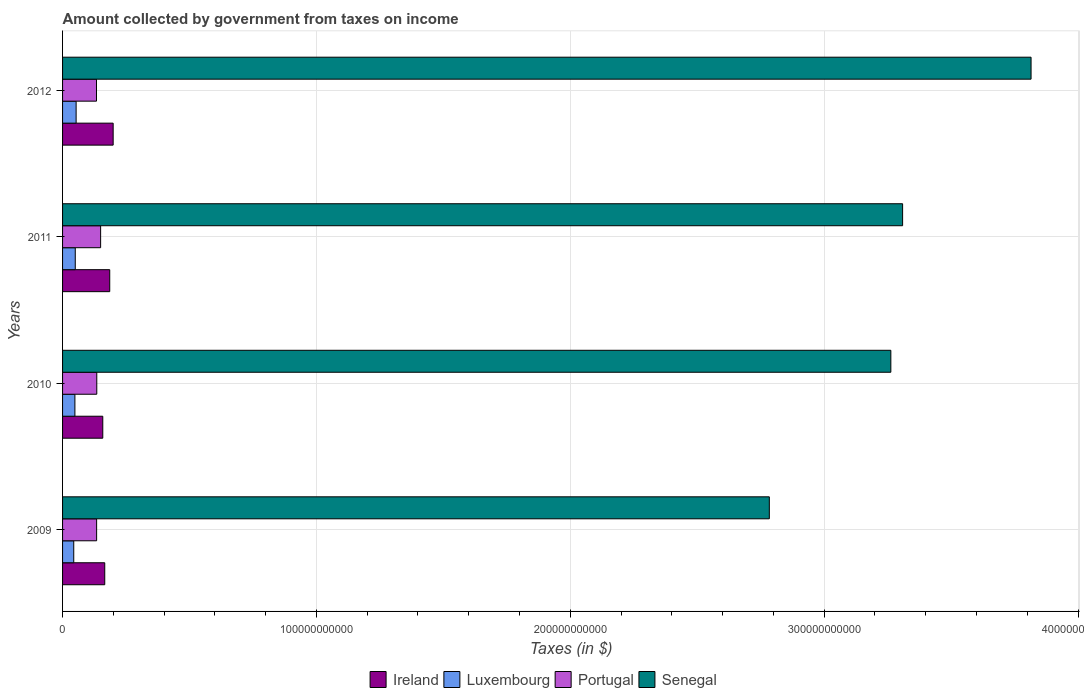How many different coloured bars are there?
Make the answer very short. 4. How many groups of bars are there?
Make the answer very short. 4. Are the number of bars per tick equal to the number of legend labels?
Provide a short and direct response. Yes. Are the number of bars on each tick of the Y-axis equal?
Make the answer very short. Yes. How many bars are there on the 1st tick from the bottom?
Ensure brevity in your answer.  4. What is the amount collected by government from taxes on income in Senegal in 2009?
Your response must be concise. 2.78e+11. Across all years, what is the maximum amount collected by government from taxes on income in Portugal?
Your answer should be very brief. 1.50e+1. Across all years, what is the minimum amount collected by government from taxes on income in Senegal?
Give a very brief answer. 2.78e+11. In which year was the amount collected by government from taxes on income in Senegal minimum?
Offer a very short reply. 2009. What is the total amount collected by government from taxes on income in Ireland in the graph?
Keep it short and to the point. 7.10e+1. What is the difference between the amount collected by government from taxes on income in Ireland in 2010 and that in 2012?
Provide a succinct answer. -4.09e+09. What is the difference between the amount collected by government from taxes on income in Portugal in 2010 and the amount collected by government from taxes on income in Ireland in 2009?
Offer a terse response. -3.14e+09. What is the average amount collected by government from taxes on income in Luxembourg per year?
Offer a terse response. 4.90e+09. In the year 2011, what is the difference between the amount collected by government from taxes on income in Senegal and amount collected by government from taxes on income in Ireland?
Make the answer very short. 3.12e+11. In how many years, is the amount collected by government from taxes on income in Portugal greater than 20000000000 $?
Your response must be concise. 0. What is the ratio of the amount collected by government from taxes on income in Senegal in 2009 to that in 2010?
Your answer should be very brief. 0.85. Is the difference between the amount collected by government from taxes on income in Senegal in 2009 and 2010 greater than the difference between the amount collected by government from taxes on income in Ireland in 2009 and 2010?
Keep it short and to the point. No. What is the difference between the highest and the second highest amount collected by government from taxes on income in Ireland?
Provide a short and direct response. 1.35e+09. What is the difference between the highest and the lowest amount collected by government from taxes on income in Senegal?
Make the answer very short. 1.03e+11. Is it the case that in every year, the sum of the amount collected by government from taxes on income in Portugal and amount collected by government from taxes on income in Luxembourg is greater than the sum of amount collected by government from taxes on income in Ireland and amount collected by government from taxes on income in Senegal?
Offer a terse response. No. What does the 2nd bar from the bottom in 2010 represents?
Offer a very short reply. Luxembourg. Is it the case that in every year, the sum of the amount collected by government from taxes on income in Luxembourg and amount collected by government from taxes on income in Portugal is greater than the amount collected by government from taxes on income in Senegal?
Provide a succinct answer. No. How many years are there in the graph?
Your answer should be compact. 4. What is the difference between two consecutive major ticks on the X-axis?
Your response must be concise. 1.00e+11. How many legend labels are there?
Offer a terse response. 4. What is the title of the graph?
Your answer should be compact. Amount collected by government from taxes on income. Does "Ecuador" appear as one of the legend labels in the graph?
Provide a short and direct response. No. What is the label or title of the X-axis?
Your answer should be compact. Taxes (in $). What is the Taxes (in $) of Ireland in 2009?
Give a very brief answer. 1.66e+1. What is the Taxes (in $) of Luxembourg in 2009?
Keep it short and to the point. 4.41e+09. What is the Taxes (in $) of Portugal in 2009?
Give a very brief answer. 1.34e+1. What is the Taxes (in $) of Senegal in 2009?
Your response must be concise. 2.78e+11. What is the Taxes (in $) in Ireland in 2010?
Ensure brevity in your answer.  1.58e+1. What is the Taxes (in $) of Luxembourg in 2010?
Give a very brief answer. 4.86e+09. What is the Taxes (in $) of Portugal in 2010?
Offer a terse response. 1.35e+1. What is the Taxes (in $) of Senegal in 2010?
Offer a very short reply. 3.26e+11. What is the Taxes (in $) of Ireland in 2011?
Your response must be concise. 1.86e+1. What is the Taxes (in $) in Luxembourg in 2011?
Ensure brevity in your answer.  5.00e+09. What is the Taxes (in $) in Portugal in 2011?
Give a very brief answer. 1.50e+1. What is the Taxes (in $) in Senegal in 2011?
Provide a short and direct response. 3.31e+11. What is the Taxes (in $) of Ireland in 2012?
Your answer should be compact. 1.99e+1. What is the Taxes (in $) in Luxembourg in 2012?
Ensure brevity in your answer.  5.34e+09. What is the Taxes (in $) in Portugal in 2012?
Provide a short and direct response. 1.34e+1. What is the Taxes (in $) in Senegal in 2012?
Ensure brevity in your answer.  3.82e+11. Across all years, what is the maximum Taxes (in $) of Ireland?
Offer a very short reply. 1.99e+1. Across all years, what is the maximum Taxes (in $) in Luxembourg?
Provide a short and direct response. 5.34e+09. Across all years, what is the maximum Taxes (in $) in Portugal?
Make the answer very short. 1.50e+1. Across all years, what is the maximum Taxes (in $) in Senegal?
Ensure brevity in your answer.  3.82e+11. Across all years, what is the minimum Taxes (in $) in Ireland?
Provide a short and direct response. 1.58e+1. Across all years, what is the minimum Taxes (in $) of Luxembourg?
Give a very brief answer. 4.41e+09. Across all years, what is the minimum Taxes (in $) of Portugal?
Keep it short and to the point. 1.34e+1. Across all years, what is the minimum Taxes (in $) in Senegal?
Offer a terse response. 2.78e+11. What is the total Taxes (in $) of Ireland in the graph?
Provide a succinct answer. 7.10e+1. What is the total Taxes (in $) of Luxembourg in the graph?
Provide a succinct answer. 1.96e+1. What is the total Taxes (in $) in Portugal in the graph?
Your answer should be compact. 5.53e+1. What is the total Taxes (in $) in Senegal in the graph?
Keep it short and to the point. 1.32e+12. What is the difference between the Taxes (in $) in Ireland in 2009 and that in 2010?
Your answer should be compact. 7.74e+08. What is the difference between the Taxes (in $) in Luxembourg in 2009 and that in 2010?
Make the answer very short. -4.57e+08. What is the difference between the Taxes (in $) of Portugal in 2009 and that in 2010?
Give a very brief answer. -6.13e+07. What is the difference between the Taxes (in $) in Senegal in 2009 and that in 2010?
Your answer should be very brief. -4.79e+1. What is the difference between the Taxes (in $) of Ireland in 2009 and that in 2011?
Provide a succinct answer. -1.97e+09. What is the difference between the Taxes (in $) of Luxembourg in 2009 and that in 2011?
Provide a succinct answer. -5.97e+08. What is the difference between the Taxes (in $) in Portugal in 2009 and that in 2011?
Provide a succinct answer. -1.57e+09. What is the difference between the Taxes (in $) of Senegal in 2009 and that in 2011?
Keep it short and to the point. -5.25e+1. What is the difference between the Taxes (in $) in Ireland in 2009 and that in 2012?
Make the answer very short. -3.32e+09. What is the difference between the Taxes (in $) of Luxembourg in 2009 and that in 2012?
Make the answer very short. -9.32e+08. What is the difference between the Taxes (in $) of Portugal in 2009 and that in 2012?
Your answer should be compact. 4.89e+07. What is the difference between the Taxes (in $) of Senegal in 2009 and that in 2012?
Provide a short and direct response. -1.03e+11. What is the difference between the Taxes (in $) of Ireland in 2010 and that in 2011?
Your answer should be very brief. -2.74e+09. What is the difference between the Taxes (in $) in Luxembourg in 2010 and that in 2011?
Your response must be concise. -1.40e+08. What is the difference between the Taxes (in $) of Portugal in 2010 and that in 2011?
Give a very brief answer. -1.51e+09. What is the difference between the Taxes (in $) in Senegal in 2010 and that in 2011?
Provide a succinct answer. -4.64e+09. What is the difference between the Taxes (in $) in Ireland in 2010 and that in 2012?
Your answer should be very brief. -4.09e+09. What is the difference between the Taxes (in $) of Luxembourg in 2010 and that in 2012?
Provide a short and direct response. -4.75e+08. What is the difference between the Taxes (in $) in Portugal in 2010 and that in 2012?
Make the answer very short. 1.10e+08. What is the difference between the Taxes (in $) in Senegal in 2010 and that in 2012?
Provide a succinct answer. -5.52e+1. What is the difference between the Taxes (in $) of Ireland in 2011 and that in 2012?
Provide a short and direct response. -1.35e+09. What is the difference between the Taxes (in $) in Luxembourg in 2011 and that in 2012?
Ensure brevity in your answer.  -3.36e+08. What is the difference between the Taxes (in $) of Portugal in 2011 and that in 2012?
Offer a terse response. 1.62e+09. What is the difference between the Taxes (in $) in Senegal in 2011 and that in 2012?
Ensure brevity in your answer.  -5.06e+1. What is the difference between the Taxes (in $) in Ireland in 2009 and the Taxes (in $) in Luxembourg in 2010?
Ensure brevity in your answer.  1.18e+1. What is the difference between the Taxes (in $) of Ireland in 2009 and the Taxes (in $) of Portugal in 2010?
Offer a terse response. 3.14e+09. What is the difference between the Taxes (in $) of Ireland in 2009 and the Taxes (in $) of Senegal in 2010?
Offer a very short reply. -3.10e+11. What is the difference between the Taxes (in $) of Luxembourg in 2009 and the Taxes (in $) of Portugal in 2010?
Offer a very short reply. -9.07e+09. What is the difference between the Taxes (in $) in Luxembourg in 2009 and the Taxes (in $) in Senegal in 2010?
Give a very brief answer. -3.22e+11. What is the difference between the Taxes (in $) in Portugal in 2009 and the Taxes (in $) in Senegal in 2010?
Offer a very short reply. -3.13e+11. What is the difference between the Taxes (in $) in Ireland in 2009 and the Taxes (in $) in Luxembourg in 2011?
Your answer should be compact. 1.16e+1. What is the difference between the Taxes (in $) in Ireland in 2009 and the Taxes (in $) in Portugal in 2011?
Ensure brevity in your answer.  1.62e+09. What is the difference between the Taxes (in $) of Ireland in 2009 and the Taxes (in $) of Senegal in 2011?
Ensure brevity in your answer.  -3.14e+11. What is the difference between the Taxes (in $) in Luxembourg in 2009 and the Taxes (in $) in Portugal in 2011?
Ensure brevity in your answer.  -1.06e+1. What is the difference between the Taxes (in $) in Luxembourg in 2009 and the Taxes (in $) in Senegal in 2011?
Offer a very short reply. -3.26e+11. What is the difference between the Taxes (in $) of Portugal in 2009 and the Taxes (in $) of Senegal in 2011?
Offer a terse response. -3.17e+11. What is the difference between the Taxes (in $) of Ireland in 2009 and the Taxes (in $) of Luxembourg in 2012?
Make the answer very short. 1.13e+1. What is the difference between the Taxes (in $) of Ireland in 2009 and the Taxes (in $) of Portugal in 2012?
Provide a succinct answer. 3.25e+09. What is the difference between the Taxes (in $) of Ireland in 2009 and the Taxes (in $) of Senegal in 2012?
Provide a succinct answer. -3.65e+11. What is the difference between the Taxes (in $) of Luxembourg in 2009 and the Taxes (in $) of Portugal in 2012?
Give a very brief answer. -8.96e+09. What is the difference between the Taxes (in $) in Luxembourg in 2009 and the Taxes (in $) in Senegal in 2012?
Your answer should be compact. -3.77e+11. What is the difference between the Taxes (in $) of Portugal in 2009 and the Taxes (in $) of Senegal in 2012?
Keep it short and to the point. -3.68e+11. What is the difference between the Taxes (in $) of Ireland in 2010 and the Taxes (in $) of Luxembourg in 2011?
Give a very brief answer. 1.08e+1. What is the difference between the Taxes (in $) of Ireland in 2010 and the Taxes (in $) of Portugal in 2011?
Your answer should be very brief. 8.49e+08. What is the difference between the Taxes (in $) in Ireland in 2010 and the Taxes (in $) in Senegal in 2011?
Provide a succinct answer. -3.15e+11. What is the difference between the Taxes (in $) of Luxembourg in 2010 and the Taxes (in $) of Portugal in 2011?
Your answer should be very brief. -1.01e+1. What is the difference between the Taxes (in $) of Luxembourg in 2010 and the Taxes (in $) of Senegal in 2011?
Provide a short and direct response. -3.26e+11. What is the difference between the Taxes (in $) of Portugal in 2010 and the Taxes (in $) of Senegal in 2011?
Make the answer very short. -3.17e+11. What is the difference between the Taxes (in $) in Ireland in 2010 and the Taxes (in $) in Luxembourg in 2012?
Your response must be concise. 1.05e+1. What is the difference between the Taxes (in $) in Ireland in 2010 and the Taxes (in $) in Portugal in 2012?
Your answer should be compact. 2.47e+09. What is the difference between the Taxes (in $) of Ireland in 2010 and the Taxes (in $) of Senegal in 2012?
Keep it short and to the point. -3.66e+11. What is the difference between the Taxes (in $) in Luxembourg in 2010 and the Taxes (in $) in Portugal in 2012?
Offer a very short reply. -8.51e+09. What is the difference between the Taxes (in $) in Luxembourg in 2010 and the Taxes (in $) in Senegal in 2012?
Offer a very short reply. -3.77e+11. What is the difference between the Taxes (in $) of Portugal in 2010 and the Taxes (in $) of Senegal in 2012?
Your answer should be compact. -3.68e+11. What is the difference between the Taxes (in $) in Ireland in 2011 and the Taxes (in $) in Luxembourg in 2012?
Keep it short and to the point. 1.32e+1. What is the difference between the Taxes (in $) in Ireland in 2011 and the Taxes (in $) in Portugal in 2012?
Offer a very short reply. 5.21e+09. What is the difference between the Taxes (in $) in Ireland in 2011 and the Taxes (in $) in Senegal in 2012?
Give a very brief answer. -3.63e+11. What is the difference between the Taxes (in $) of Luxembourg in 2011 and the Taxes (in $) of Portugal in 2012?
Your answer should be compact. -8.37e+09. What is the difference between the Taxes (in $) of Luxembourg in 2011 and the Taxes (in $) of Senegal in 2012?
Give a very brief answer. -3.76e+11. What is the difference between the Taxes (in $) in Portugal in 2011 and the Taxes (in $) in Senegal in 2012?
Provide a short and direct response. -3.67e+11. What is the average Taxes (in $) of Ireland per year?
Your answer should be compact. 1.77e+1. What is the average Taxes (in $) in Luxembourg per year?
Ensure brevity in your answer.  4.90e+09. What is the average Taxes (in $) in Portugal per year?
Your answer should be compact. 1.38e+1. What is the average Taxes (in $) of Senegal per year?
Provide a short and direct response. 3.29e+11. In the year 2009, what is the difference between the Taxes (in $) in Ireland and Taxes (in $) in Luxembourg?
Offer a very short reply. 1.22e+1. In the year 2009, what is the difference between the Taxes (in $) in Ireland and Taxes (in $) in Portugal?
Give a very brief answer. 3.20e+09. In the year 2009, what is the difference between the Taxes (in $) in Ireland and Taxes (in $) in Senegal?
Offer a terse response. -2.62e+11. In the year 2009, what is the difference between the Taxes (in $) of Luxembourg and Taxes (in $) of Portugal?
Your answer should be very brief. -9.01e+09. In the year 2009, what is the difference between the Taxes (in $) of Luxembourg and Taxes (in $) of Senegal?
Make the answer very short. -2.74e+11. In the year 2009, what is the difference between the Taxes (in $) of Portugal and Taxes (in $) of Senegal?
Your answer should be very brief. -2.65e+11. In the year 2010, what is the difference between the Taxes (in $) of Ireland and Taxes (in $) of Luxembourg?
Ensure brevity in your answer.  1.10e+1. In the year 2010, what is the difference between the Taxes (in $) in Ireland and Taxes (in $) in Portugal?
Provide a short and direct response. 2.36e+09. In the year 2010, what is the difference between the Taxes (in $) of Ireland and Taxes (in $) of Senegal?
Provide a short and direct response. -3.10e+11. In the year 2010, what is the difference between the Taxes (in $) in Luxembourg and Taxes (in $) in Portugal?
Offer a very short reply. -8.62e+09. In the year 2010, what is the difference between the Taxes (in $) in Luxembourg and Taxes (in $) in Senegal?
Offer a terse response. -3.21e+11. In the year 2010, what is the difference between the Taxes (in $) of Portugal and Taxes (in $) of Senegal?
Provide a succinct answer. -3.13e+11. In the year 2011, what is the difference between the Taxes (in $) of Ireland and Taxes (in $) of Luxembourg?
Keep it short and to the point. 1.36e+1. In the year 2011, what is the difference between the Taxes (in $) in Ireland and Taxes (in $) in Portugal?
Your response must be concise. 3.59e+09. In the year 2011, what is the difference between the Taxes (in $) of Ireland and Taxes (in $) of Senegal?
Provide a short and direct response. -3.12e+11. In the year 2011, what is the difference between the Taxes (in $) of Luxembourg and Taxes (in $) of Portugal?
Your response must be concise. -9.99e+09. In the year 2011, what is the difference between the Taxes (in $) of Luxembourg and Taxes (in $) of Senegal?
Offer a very short reply. -3.26e+11. In the year 2011, what is the difference between the Taxes (in $) in Portugal and Taxes (in $) in Senegal?
Your answer should be compact. -3.16e+11. In the year 2012, what is the difference between the Taxes (in $) in Ireland and Taxes (in $) in Luxembourg?
Provide a succinct answer. 1.46e+1. In the year 2012, what is the difference between the Taxes (in $) in Ireland and Taxes (in $) in Portugal?
Keep it short and to the point. 6.56e+09. In the year 2012, what is the difference between the Taxes (in $) of Ireland and Taxes (in $) of Senegal?
Provide a short and direct response. -3.62e+11. In the year 2012, what is the difference between the Taxes (in $) of Luxembourg and Taxes (in $) of Portugal?
Give a very brief answer. -8.03e+09. In the year 2012, what is the difference between the Taxes (in $) of Luxembourg and Taxes (in $) of Senegal?
Your answer should be compact. -3.76e+11. In the year 2012, what is the difference between the Taxes (in $) of Portugal and Taxes (in $) of Senegal?
Provide a succinct answer. -3.68e+11. What is the ratio of the Taxes (in $) in Ireland in 2009 to that in 2010?
Ensure brevity in your answer.  1.05. What is the ratio of the Taxes (in $) in Luxembourg in 2009 to that in 2010?
Your answer should be very brief. 0.91. What is the ratio of the Taxes (in $) in Portugal in 2009 to that in 2010?
Your answer should be compact. 1. What is the ratio of the Taxes (in $) in Senegal in 2009 to that in 2010?
Keep it short and to the point. 0.85. What is the ratio of the Taxes (in $) of Ireland in 2009 to that in 2011?
Your response must be concise. 0.89. What is the ratio of the Taxes (in $) in Luxembourg in 2009 to that in 2011?
Offer a terse response. 0.88. What is the ratio of the Taxes (in $) in Portugal in 2009 to that in 2011?
Your answer should be compact. 0.9. What is the ratio of the Taxes (in $) of Senegal in 2009 to that in 2011?
Keep it short and to the point. 0.84. What is the ratio of the Taxes (in $) of Ireland in 2009 to that in 2012?
Ensure brevity in your answer.  0.83. What is the ratio of the Taxes (in $) of Luxembourg in 2009 to that in 2012?
Your answer should be compact. 0.83. What is the ratio of the Taxes (in $) in Portugal in 2009 to that in 2012?
Your answer should be very brief. 1. What is the ratio of the Taxes (in $) in Senegal in 2009 to that in 2012?
Your answer should be compact. 0.73. What is the ratio of the Taxes (in $) in Ireland in 2010 to that in 2011?
Make the answer very short. 0.85. What is the ratio of the Taxes (in $) in Luxembourg in 2010 to that in 2011?
Provide a succinct answer. 0.97. What is the ratio of the Taxes (in $) in Portugal in 2010 to that in 2011?
Make the answer very short. 0.9. What is the ratio of the Taxes (in $) in Senegal in 2010 to that in 2011?
Give a very brief answer. 0.99. What is the ratio of the Taxes (in $) in Ireland in 2010 to that in 2012?
Offer a very short reply. 0.79. What is the ratio of the Taxes (in $) of Luxembourg in 2010 to that in 2012?
Keep it short and to the point. 0.91. What is the ratio of the Taxes (in $) of Portugal in 2010 to that in 2012?
Ensure brevity in your answer.  1.01. What is the ratio of the Taxes (in $) in Senegal in 2010 to that in 2012?
Your answer should be compact. 0.86. What is the ratio of the Taxes (in $) in Ireland in 2011 to that in 2012?
Ensure brevity in your answer.  0.93. What is the ratio of the Taxes (in $) of Luxembourg in 2011 to that in 2012?
Your answer should be compact. 0.94. What is the ratio of the Taxes (in $) in Portugal in 2011 to that in 2012?
Ensure brevity in your answer.  1.12. What is the ratio of the Taxes (in $) in Senegal in 2011 to that in 2012?
Give a very brief answer. 0.87. What is the difference between the highest and the second highest Taxes (in $) in Ireland?
Offer a very short reply. 1.35e+09. What is the difference between the highest and the second highest Taxes (in $) of Luxembourg?
Your response must be concise. 3.36e+08. What is the difference between the highest and the second highest Taxes (in $) in Portugal?
Your answer should be very brief. 1.51e+09. What is the difference between the highest and the second highest Taxes (in $) of Senegal?
Keep it short and to the point. 5.06e+1. What is the difference between the highest and the lowest Taxes (in $) in Ireland?
Provide a succinct answer. 4.09e+09. What is the difference between the highest and the lowest Taxes (in $) of Luxembourg?
Keep it short and to the point. 9.32e+08. What is the difference between the highest and the lowest Taxes (in $) of Portugal?
Your answer should be compact. 1.62e+09. What is the difference between the highest and the lowest Taxes (in $) of Senegal?
Your answer should be compact. 1.03e+11. 